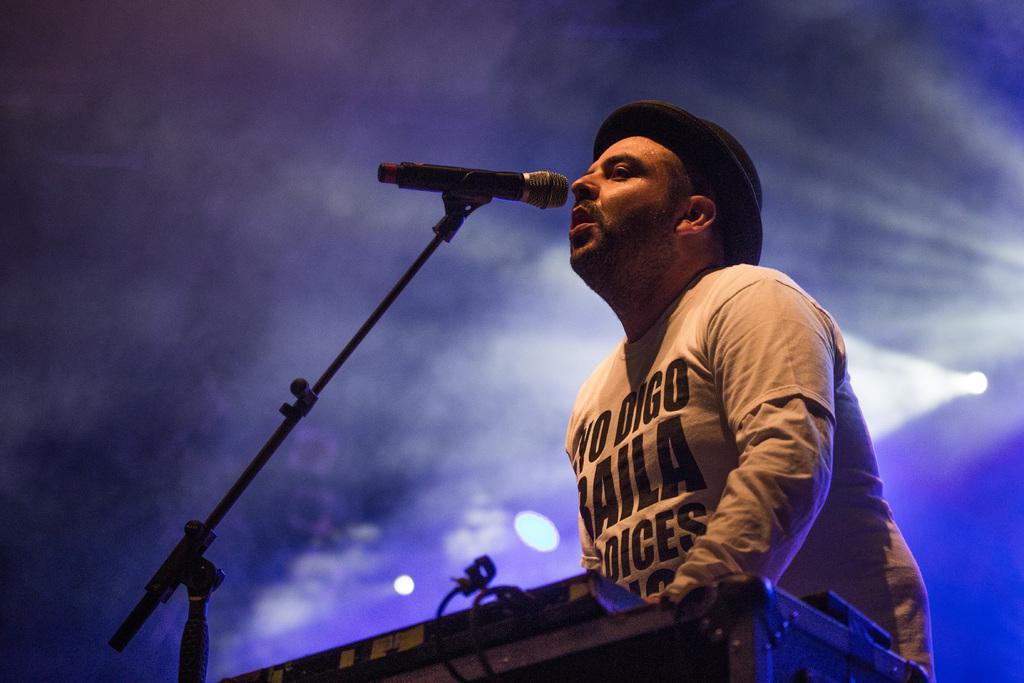Can you describe this image briefly? In this picture we can see a man, in front of him we can find a microphone, in the background we can see few lights. 